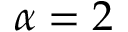Convert formula to latex. <formula><loc_0><loc_0><loc_500><loc_500>\alpha = 2</formula> 